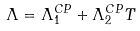<formula> <loc_0><loc_0><loc_500><loc_500>\Lambda = \Lambda ^ { C P } _ { 1 } + \Lambda ^ { C P } _ { 2 } T</formula> 